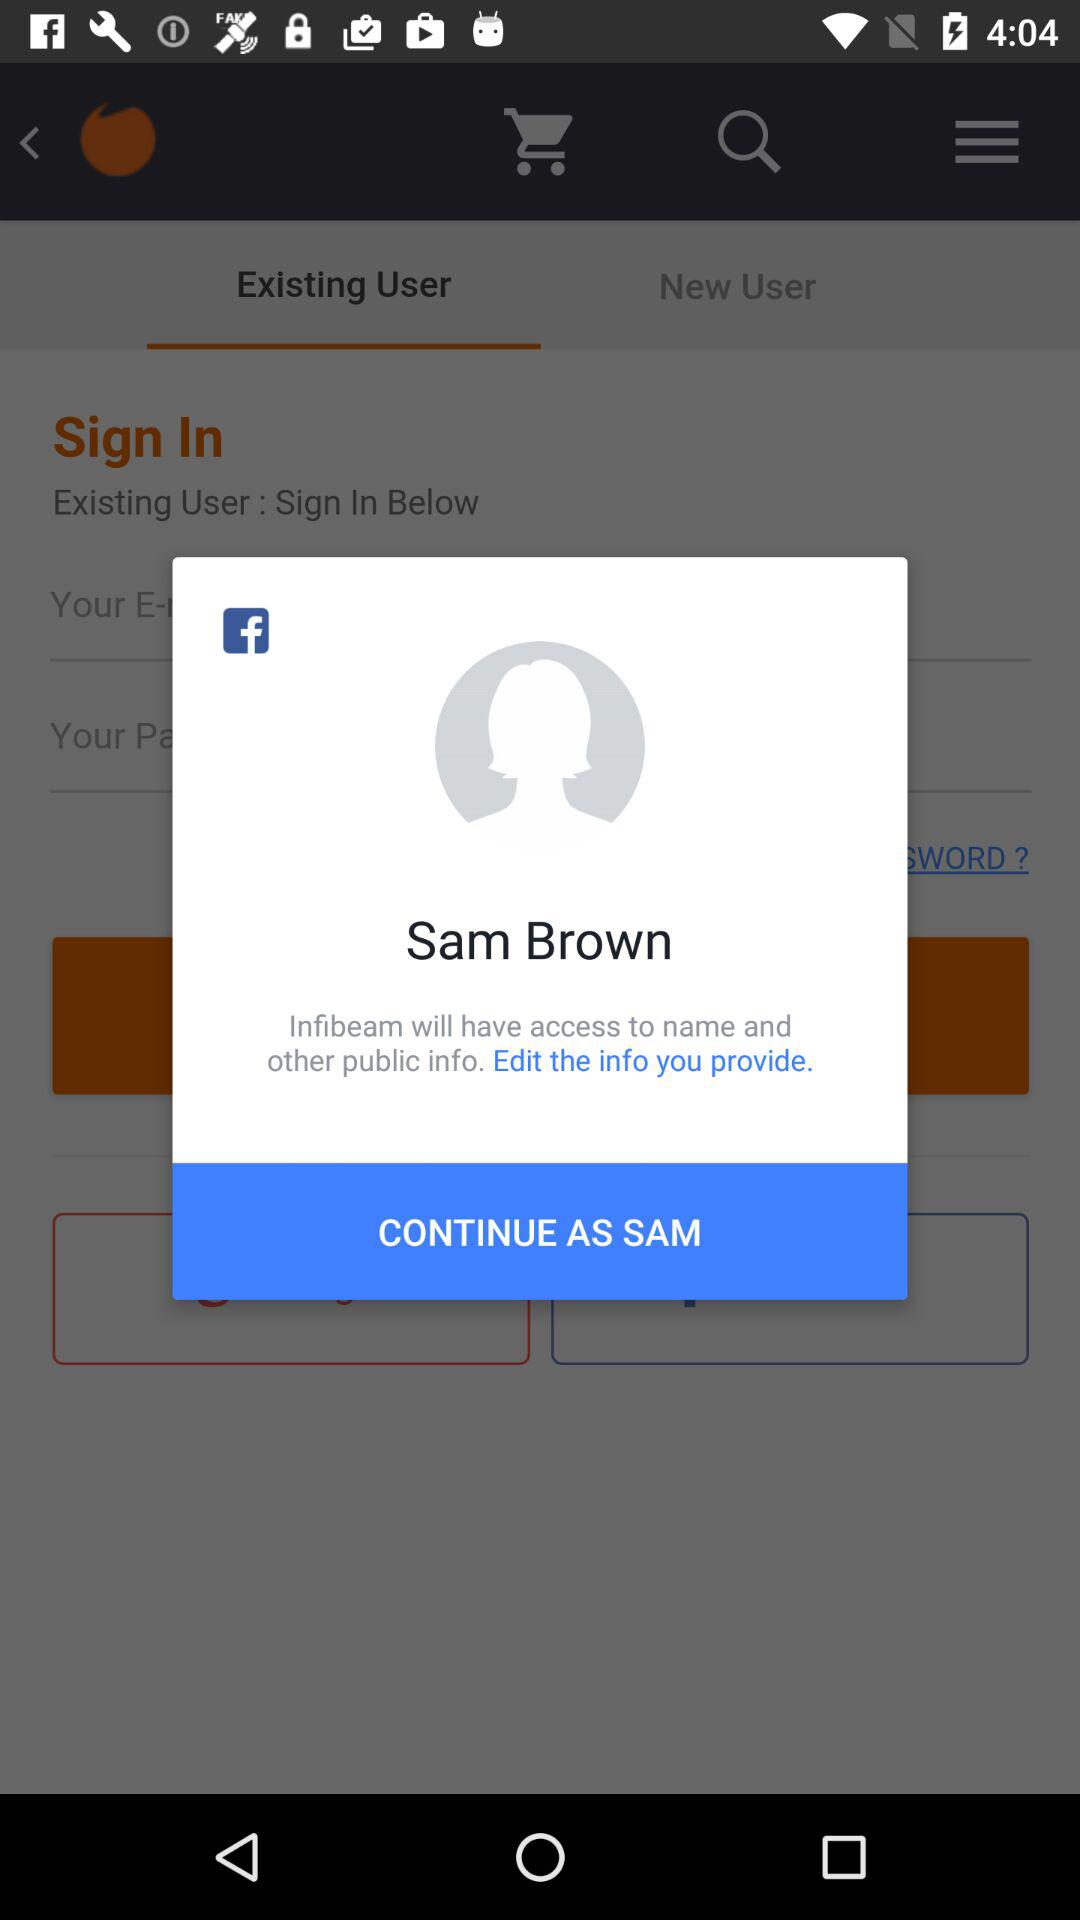What is the name of the user? The name of the user is Sam Brown. 